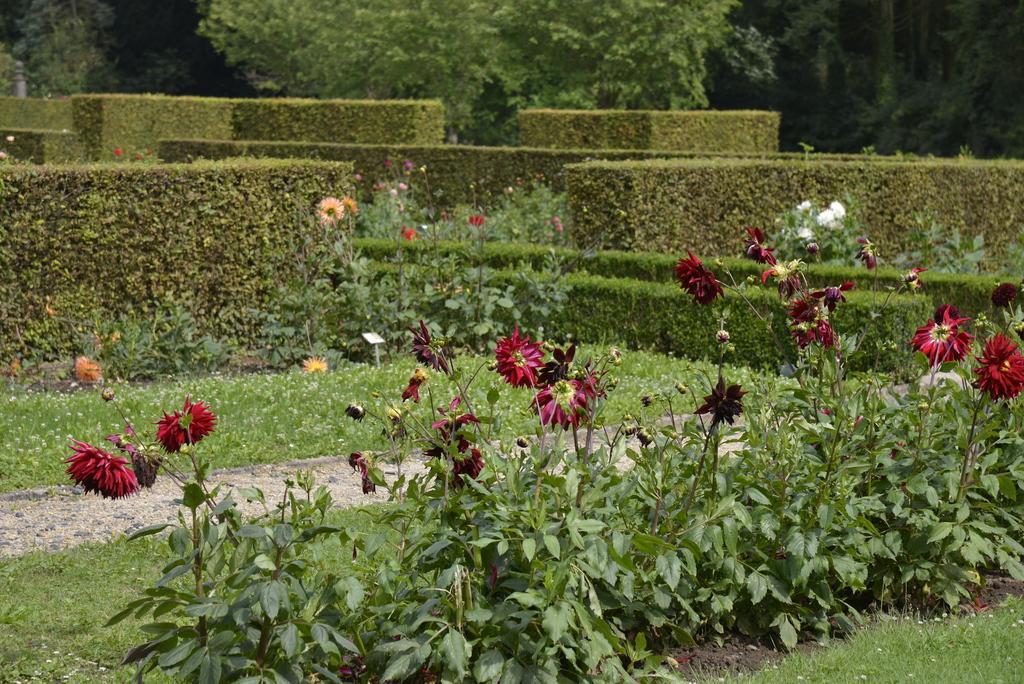Can you describe this image briefly? In this image we can see grass, plants, flowers and trees. 